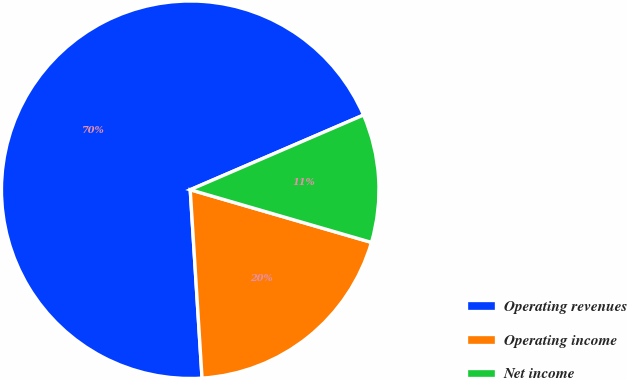Convert chart. <chart><loc_0><loc_0><loc_500><loc_500><pie_chart><fcel>Operating revenues<fcel>Operating income<fcel>Net income<nl><fcel>69.52%<fcel>19.5%<fcel>10.98%<nl></chart> 